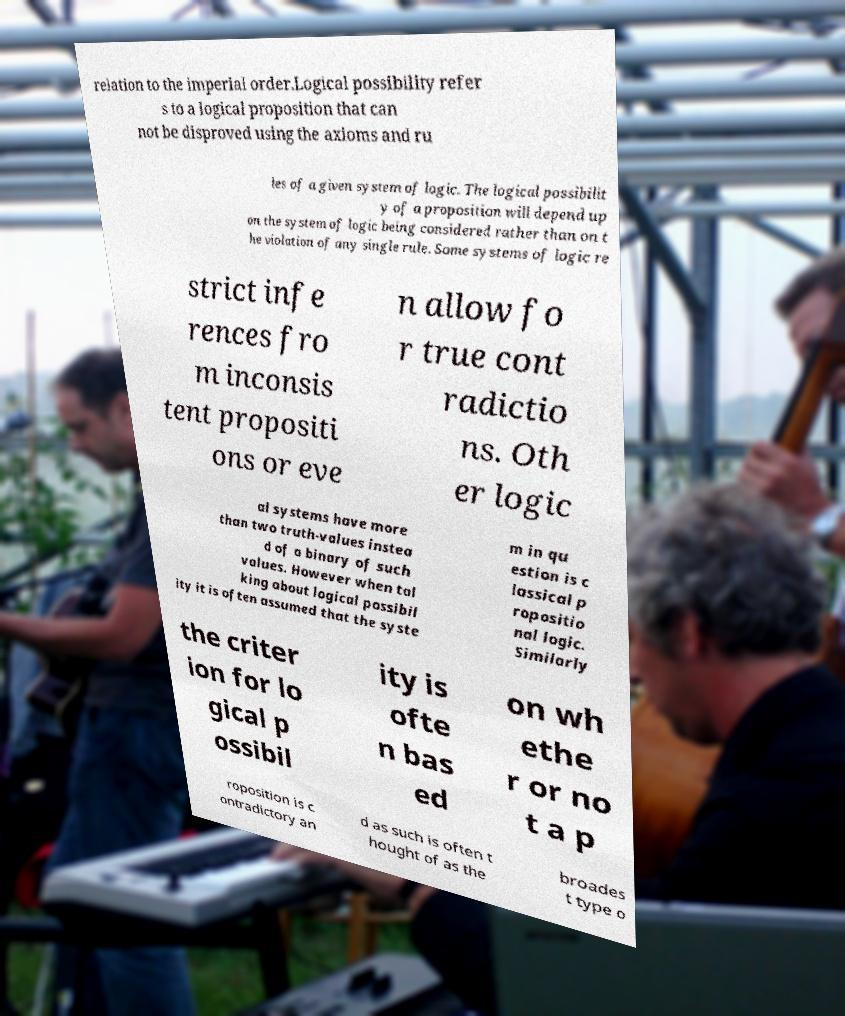There's text embedded in this image that I need extracted. Can you transcribe it verbatim? relation to the imperial order.Logical possibility refer s to a logical proposition that can not be disproved using the axioms and ru les of a given system of logic. The logical possibilit y of a proposition will depend up on the system of logic being considered rather than on t he violation of any single rule. Some systems of logic re strict infe rences fro m inconsis tent propositi ons or eve n allow fo r true cont radictio ns. Oth er logic al systems have more than two truth-values instea d of a binary of such values. However when tal king about logical possibil ity it is often assumed that the syste m in qu estion is c lassical p ropositio nal logic. Similarly the criter ion for lo gical p ossibil ity is ofte n bas ed on wh ethe r or no t a p roposition is c ontradictory an d as such is often t hought of as the broades t type o 